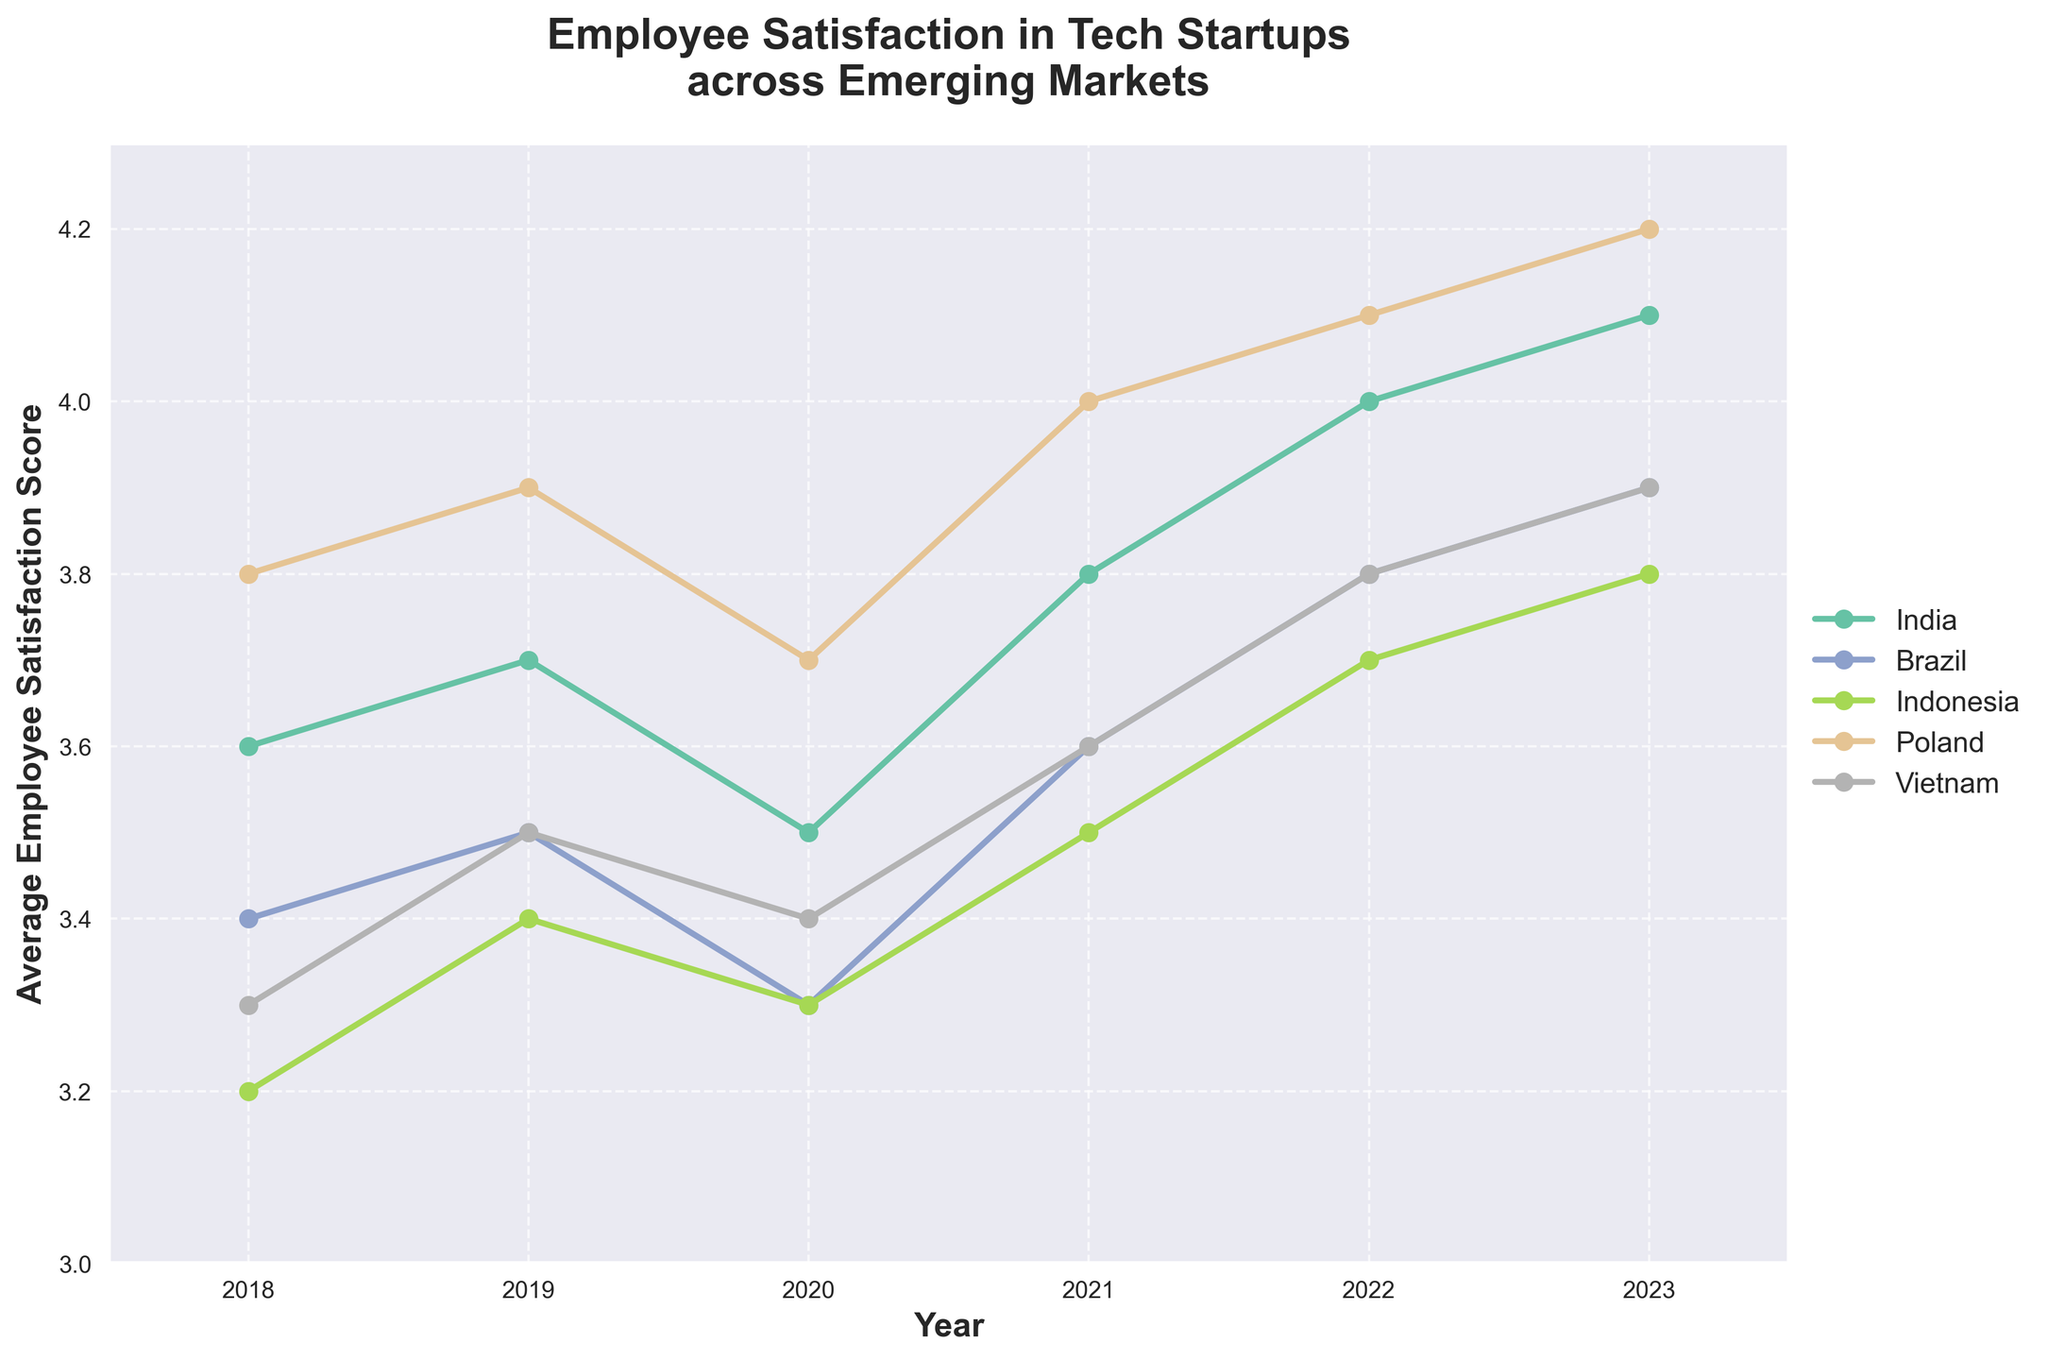What is the trend of employee satisfaction in India from 2018 to 2023? The line chart shows employee satisfaction in India increasing from 3.6 in 2018 to 4.1 in 2023.
Answer: Increasing Which country had the highest employee satisfaction score in 2023? The line chart shows that Poland had the highest score of 4.2 in 2023.
Answer: Poland Between which years did Brazil see the greatest improvement in employee satisfaction? From 2021 to 2022, the score for Brazil increased from 3.6 to 3.8.
Answer: 2021 to 2022 What is the difference in employee satisfaction between Vietnam and Indonesia in 2023? In 2023, the score for Vietnam is 3.9 and for Indonesia, it is 3.8. The difference is 3.9 - 3.8 = 0.1.
Answer: 0.1 Which country experienced a decline in employee satisfaction between 2019 and 2020? Both India and Indonesia saw a decline in satisfaction scores between 2019 and 2020, decreasing from 3.7 to 3.5 and 3.4 to 3.3 respectively.
Answer: India, Indonesia During which year did Poland have a satisfaction score of 4.0? In 2021, Poland had a satisfaction score of 4.0 according to the line chart.
Answer: 2021 Compare the satisfaction scores of Brazil and Vietnam in 2020. Which country had a higher score? In 2020, the score for Brazil was 3.3 and for Vietnam, it was 3.4. Vietnam had a higher score.
Answer: Vietnam What is the average satisfaction score for Indonesia from 2018 to 2023? Adding the scores for Indonesia from 2018 to 2023 (3.2 + 3.4 + 3.3 + 3.5 + 3.7 + 3.8) gives 20.9. Dividing by the 6 years gives 20.9 / 6 = 3.48.
Answer: 3.48 Which country's satisfaction score improved the most from 2018 to 2023? Comparing the changes from 2018 to 2023 for all countries: India (4.1-3.6=0.5), Brazil (3.9-3.4=0.5), Indonesia (3.8-3.2=0.6), Poland (4.2-3.8=0.4), Vietnam (3.9-3.3=0.6). Indonesia and Vietnam had the highest improvements of 0.6.
Answer: Indonesia, Vietnam 